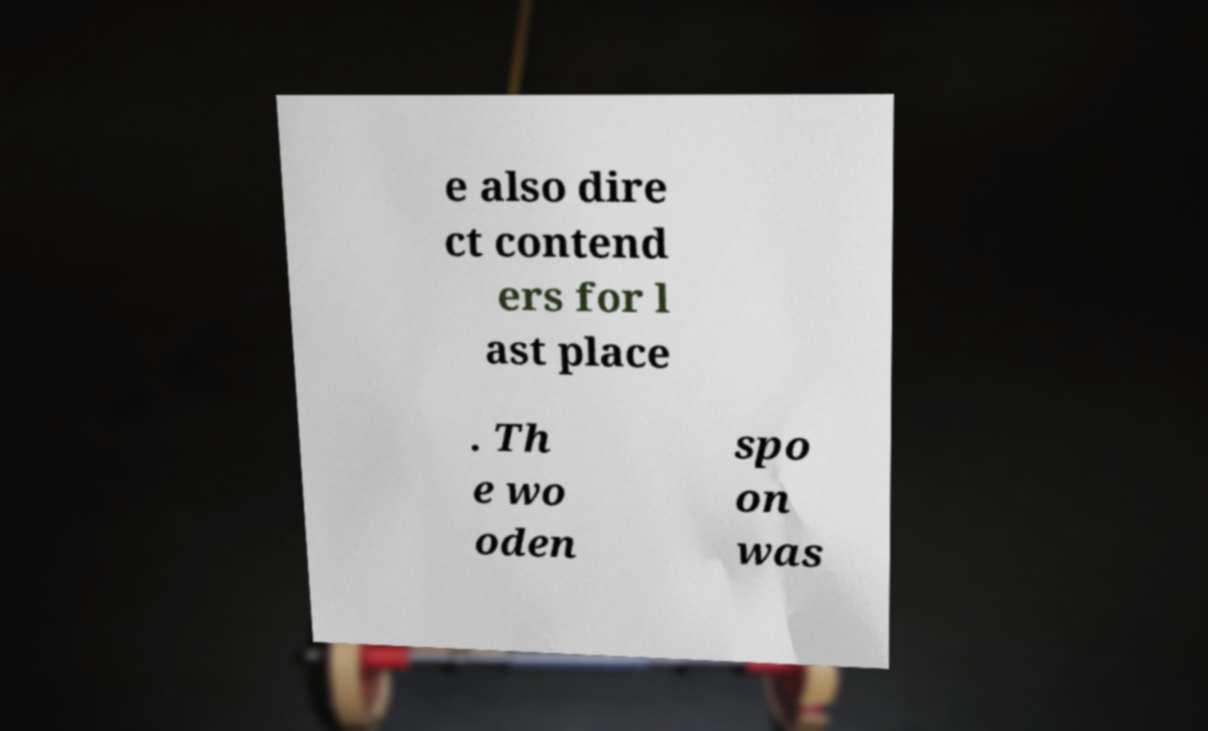For documentation purposes, I need the text within this image transcribed. Could you provide that? e also dire ct contend ers for l ast place . Th e wo oden spo on was 